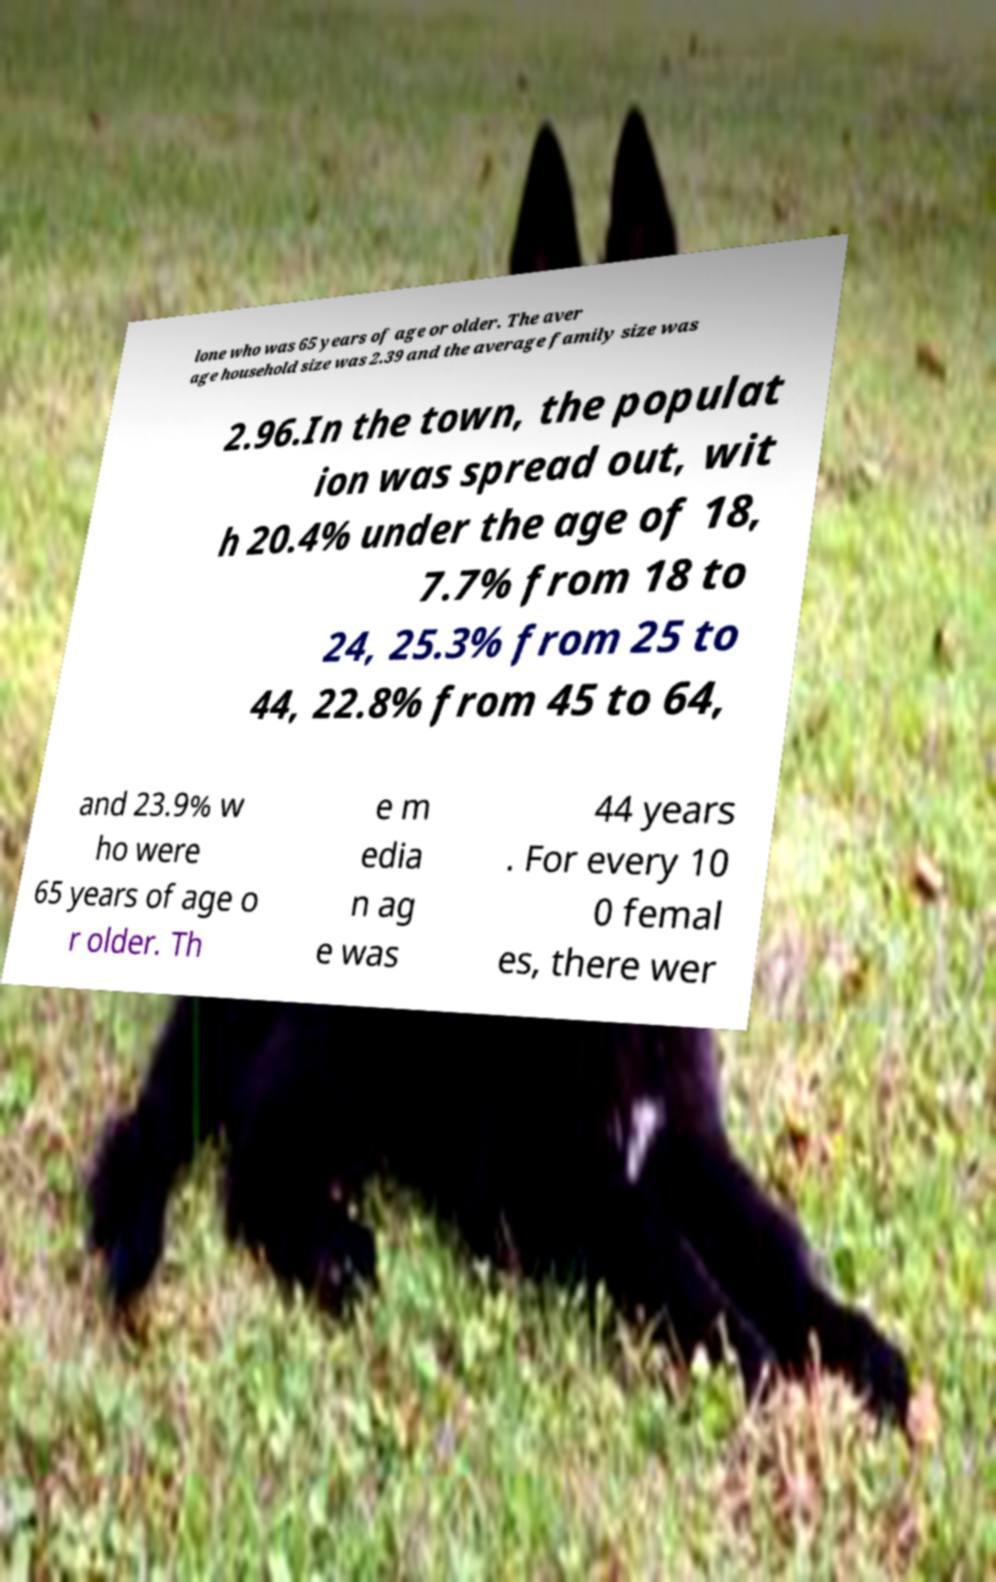I need the written content from this picture converted into text. Can you do that? lone who was 65 years of age or older. The aver age household size was 2.39 and the average family size was 2.96.In the town, the populat ion was spread out, wit h 20.4% under the age of 18, 7.7% from 18 to 24, 25.3% from 25 to 44, 22.8% from 45 to 64, and 23.9% w ho were 65 years of age o r older. Th e m edia n ag e was 44 years . For every 10 0 femal es, there wer 